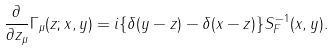Convert formula to latex. <formula><loc_0><loc_0><loc_500><loc_500>\frac { \partial } { \partial z _ { \mu } } \Gamma _ { \mu } ( z ; x , y ) = i \{ \delta ( y - z ) - \delta ( x - z ) \} S _ { F } ^ { - 1 } ( x , y ) .</formula> 